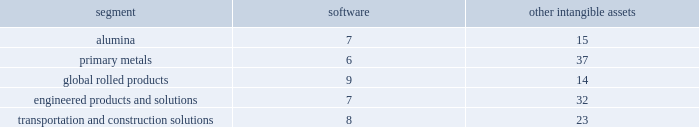During the 2015 annual review of goodwill , management proceeded directly to the two-step quantitative impairment test for two reporting units as follows : global rolled products segment and the soft alloys extrusion business in brazil ( hereafter 201csae 201d ) , which is included in the transportation and construction solutions segment .
The estimated fair value of the global rolled products segment was substantially in excess of its respective carrying value , resulting in no impairment .
For sae , the estimated fair value as determined by the dcf model was lower than the associated carrying value .
As a result , management performed the second step of the impairment analysis in order to determine the implied fair value of the sae reporting unit 2019s goodwill .
The results of the second-step analysis showed that the implied fair value of the goodwill was zero .
Therefore , in the fourth quarter of 2015 , alcoa recorded a goodwill impairment of $ 25 .
The impairment of the sae goodwill resulted from headwinds from the recent downturn in the brazilian economy and the continued erosion of gross margin despite the execution of cost reduction strategies .
As a result of the goodwill impairment , there is no goodwill remaining for the sae reporting unit .
Goodwill impairment tests in prior years indicated that goodwill was not impaired for any of the company 2019s reporting units , except for the primary metals segment in 2013 ( see below ) , and there were no triggering events since that time that necessitated an impairment test .
In 2013 , for primary metals , the estimated fair value as determined by the dcf model was lower than the associated carrying value .
As a result , management performed the second step of the impairment analysis in order to determine the implied fair value of primary metals 2019 goodwill .
The results of the second-step analysis showed that the implied fair value of goodwill was zero .
Therefore , in the fourth quarter of 2013 , alcoa recorded a goodwill impairment of $ 1731 ( $ 1719 after noncontrolling interest ) .
As a result of the goodwill impairment , there is no goodwill remaining for the primary metals reporting unit .
The impairment of primary metals 2019 goodwill resulted from several causes : the prolonged economic downturn ; a disconnect between industry fundamentals and pricing that has resulted in lower metal prices ; and the increased cost of alumina , a key raw material , resulting from expansion of the alumina price index throughout the industry .
All of these factors , exacerbated by increases in discount rates , continue to place significant downward pressure on metal prices and operating margins , and the resulting estimated fair value , of the primary metals business .
As a result , management decreased the near-term and long-term estimates of the operating results and cash flows utilized in assessing primary metals 2019 goodwill for impairment .
The valuation of goodwill for the second step of the goodwill impairment analysis is considered a level 3 fair value measurement , which means that the valuation of the assets and liabilities reflect management 2019s own judgments regarding the assumptions market participants would use in determining the fair value of the assets and liabilities .
Intangible assets with indefinite useful lives are not amortized while intangible assets with finite useful lives are amortized generally on a straight-line basis over the periods benefited .
The table details the weighted- average useful lives of software and other intangible assets by reporting segment ( numbers in years ) : .
Equity investments .
Alcoa invests in a number of privately-held companies , primarily through joint ventures and consortia , which are accounted for using the equity method .
The equity method is applied in situations where alcoa has the ability to exercise significant influence , but not control , over the investee .
Management reviews equity investments for impairment whenever certain indicators are present suggesting that the carrying value of an investment is not recoverable .
This analysis requires a significant amount of judgment from management to identify events or circumstances indicating that an equity investment is impaired .
The following items are examples of impairment indicators : significant , sustained declines in an investee 2019s revenue , earnings , and cash .
What is the decrease between the goodwill impairment recorded by alcoa during the fourth quarter of 2013 and 2015? 
Rationale: it is the difference between those two goodwill impairment recorded values .
Computations: (1731 - 25)
Answer: 1706.0. 